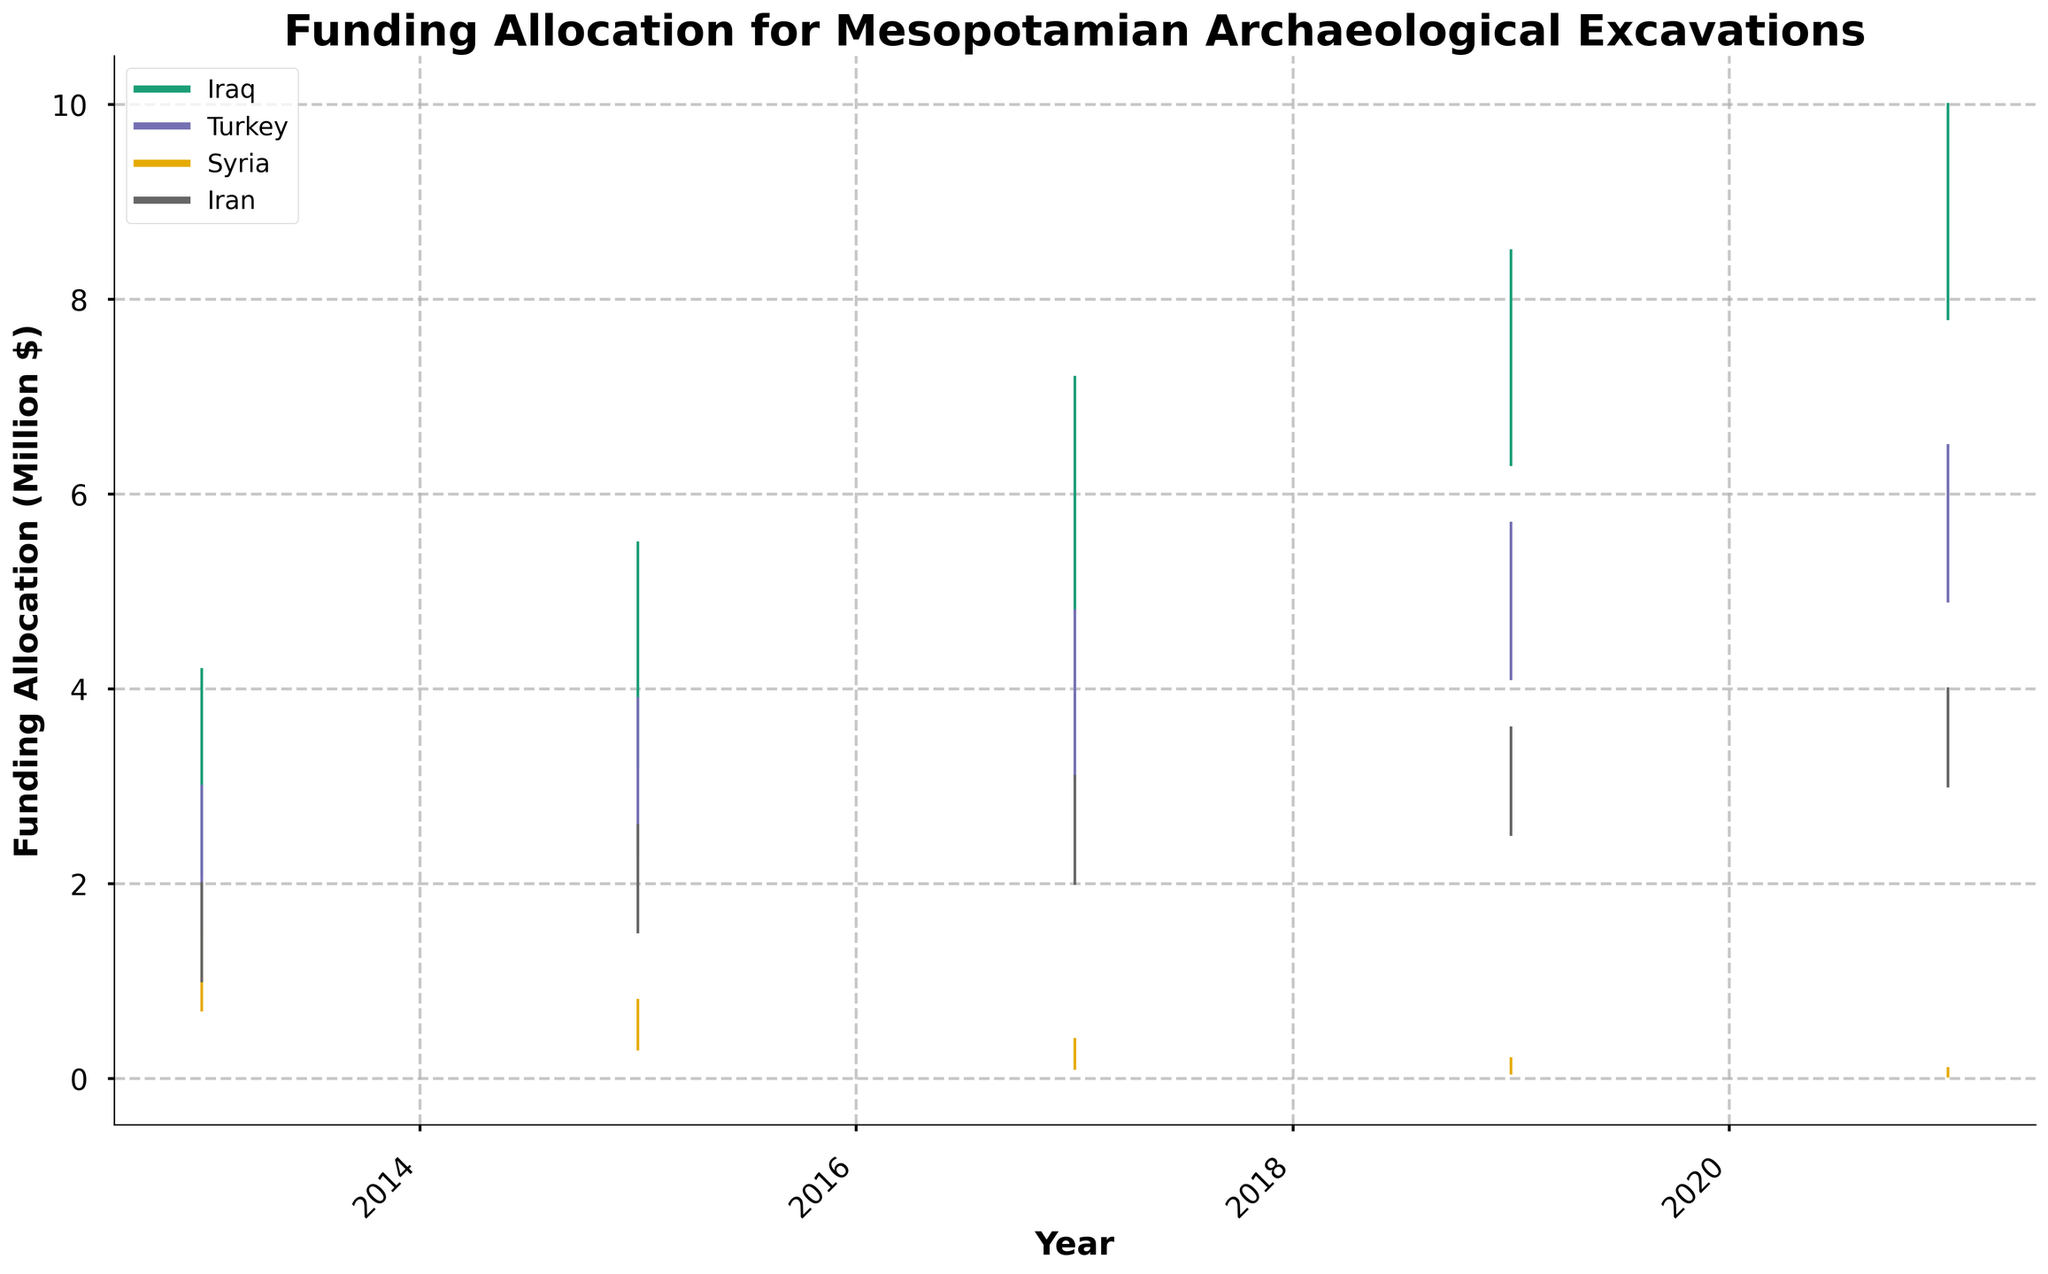What is the title of the figure? The title of the figure is displayed prominently at the top of the chart.
Answer: Funding Allocation for Mesopotamian Archaeological Excavations Which country had the highest funding allocation in 2021? In the 2021 part of the chart, Iraq has the highest "High" value among the countries represented.
Answer: Iraq How did the funding for Syria change from 2013 to 2021? By checking the "Open" and "Close" values for Syria in 2013 and 2021, you can see that it decreased from an Open of 0.9 in 2013 to a Close of 0.08 in 2021.
Answer: Decreased Which country had the most consistent increase in funding from 2013 to 2021? By comparing the trend of "Close" values over the years for each country, Iraq shows a consistent increase in funding across the years.
Answer: Iraq In which year did Turkey have the lowest funding allocation? By observing the "Low" values for Turkey across the years, 2013 shows the lowest value at 1.5.
Answer: 2013 Which country’s funding saw the largest increase between any two consecutive years? Comparing the "Close" values for each country, Iraq’s funding increased significantly from 3.8 in 2013 to 5.1 in 2015 (and even more in subsequent years).
Answer: Iraq Between 2019 and 2021, did Iran’s funding allocation increase or decrease? By comparing Iran's "Close" value from 2019 (3.3) to its "Close" value in 2021 (3.7), there is an increase in funding.
Answer: Increase What is the funding range for Syria in 2017? The range is calculated by subtracting the "Low" value from the "High" value for Syria in 2017, which is 0.4 - 0.1 = 0.3.
Answer: 0.3 Which country has the most fluctuating funding allocation over the years? Judging by the differences between the "High" and "Low" values over the years, Iraq shows the most fluctuation.
Answer: Iraq 